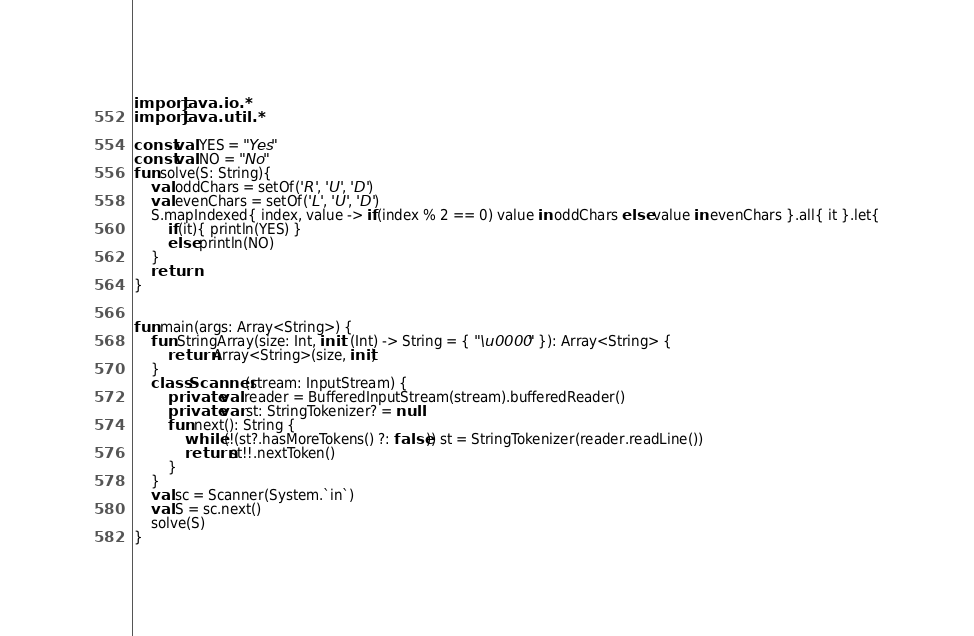Convert code to text. <code><loc_0><loc_0><loc_500><loc_500><_Kotlin_>import java.io.*
import java.util.*

const val YES = "Yes"
const val NO = "No"
fun solve(S: String){
    val oddChars = setOf('R', 'U', 'D')
    val evenChars = setOf('L', 'U', 'D')
    S.mapIndexed{ index, value -> if(index % 2 == 0) value in oddChars else value in evenChars }.all{ it }.let{
        if(it){ println(YES) }
        else println(NO)
    }
    return
}


fun main(args: Array<String>) {
    fun StringArray(size: Int, init: (Int) -> String = { "\u0000" }): Array<String> {
        return Array<String>(size, init)
    }
    class Scanner(stream: InputStream) {
        private val reader = BufferedInputStream(stream).bufferedReader()
        private var st: StringTokenizer? = null
        fun next(): String {
            while (!(st?.hasMoreTokens() ?: false)) st = StringTokenizer(reader.readLine())
            return st!!.nextToken()
        }
    }
    val sc = Scanner(System.`in`)
    val S = sc.next()
    solve(S)
}

</code> 